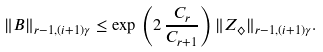Convert formula to latex. <formula><loc_0><loc_0><loc_500><loc_500>\| B \| _ { r - 1 , ( i + 1 ) \gamma } \leq \exp \, \left ( 2 \, \frac { C _ { r } } { C _ { r + 1 } } \right ) \| Z _ { \diamondsuit } \| _ { r - 1 , ( i + 1 ) \gamma } .</formula> 